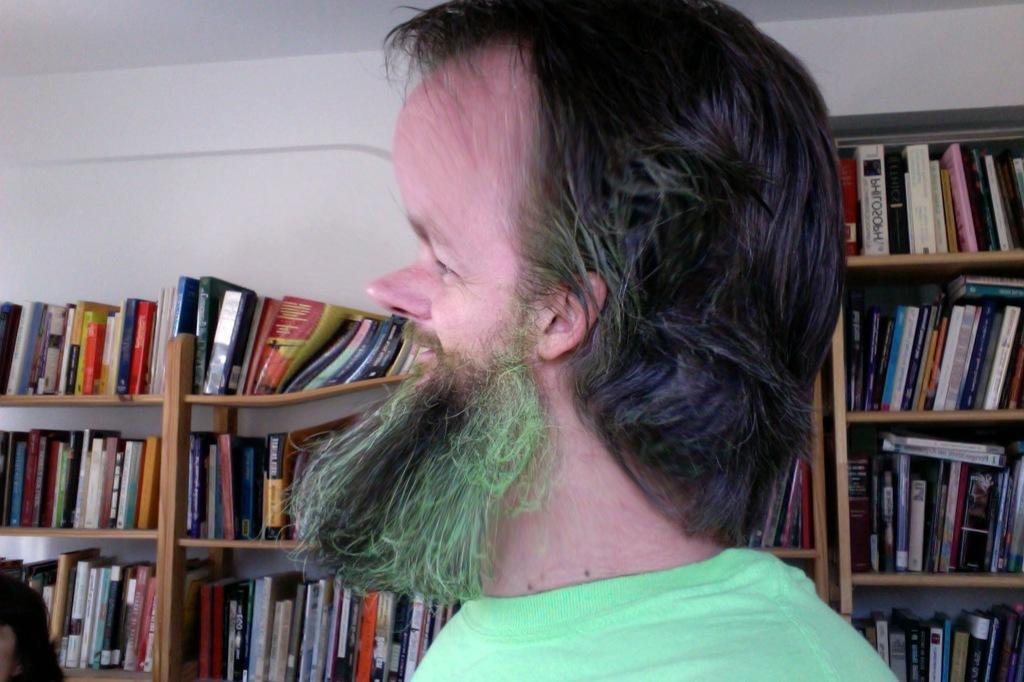How would you summarize this image in a sentence or two? In this picture I can observe a man in the middle of the picture. In the background I can observe books placed in the shelves. 